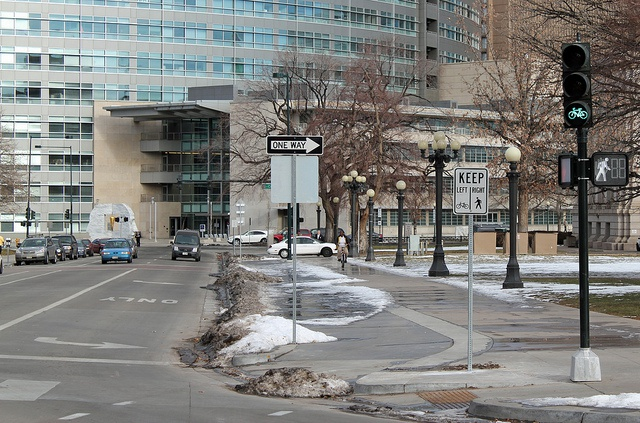Describe the objects in this image and their specific colors. I can see traffic light in white, black, gray, and teal tones, traffic light in ivory, black, gray, darkgray, and lightgray tones, car in white, lightgray, black, gray, and darkgray tones, car in ivory, gray, darkgray, black, and blue tones, and car in ivory, gray, black, purple, and darkgray tones in this image. 